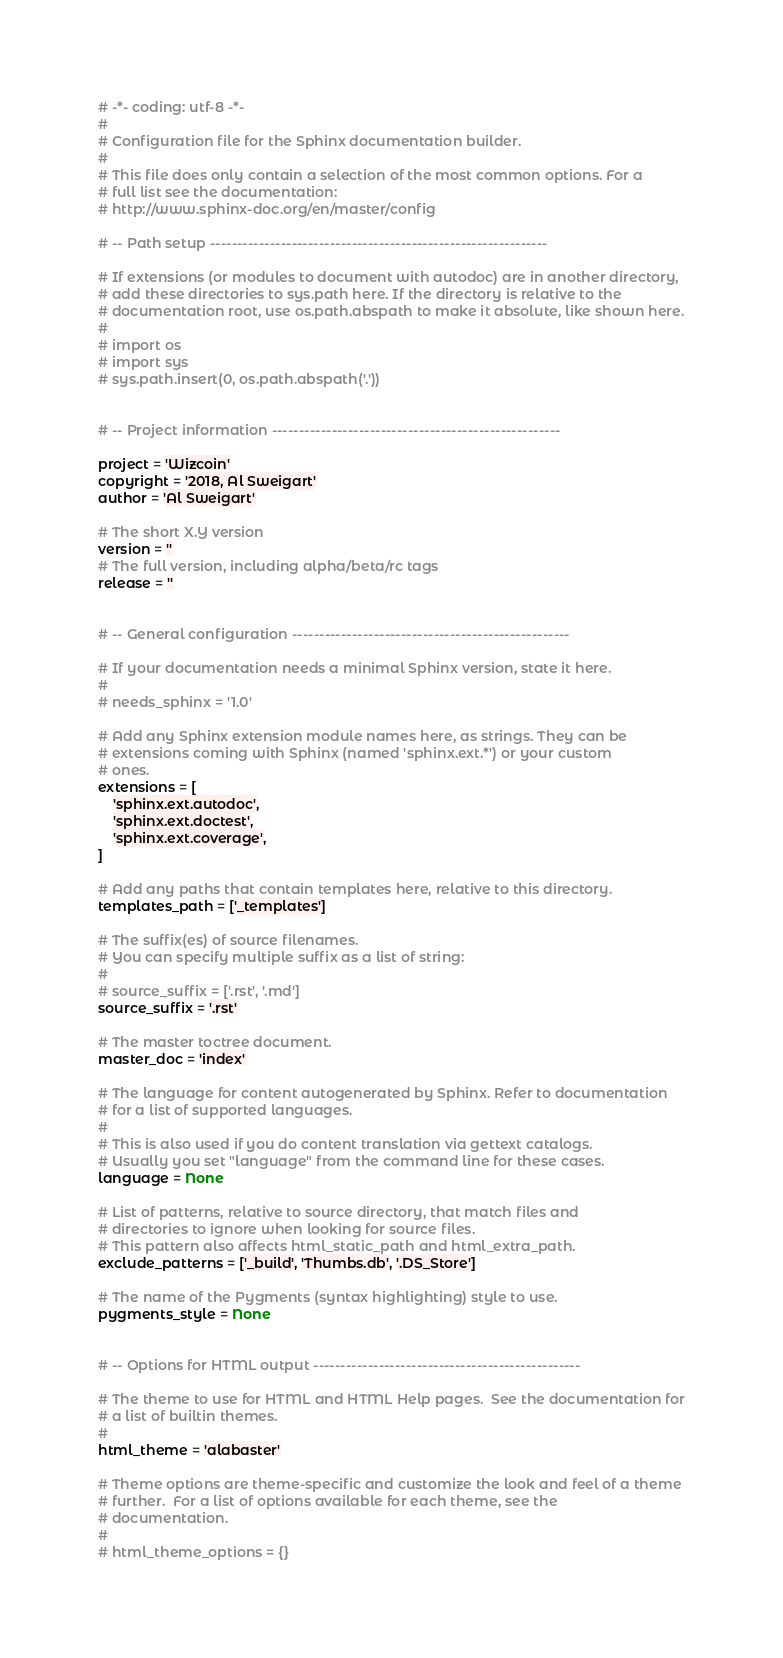Convert code to text. <code><loc_0><loc_0><loc_500><loc_500><_Python_># -*- coding: utf-8 -*-
#
# Configuration file for the Sphinx documentation builder.
#
# This file does only contain a selection of the most common options. For a
# full list see the documentation:
# http://www.sphinx-doc.org/en/master/config

# -- Path setup --------------------------------------------------------------

# If extensions (or modules to document with autodoc) are in another directory,
# add these directories to sys.path here. If the directory is relative to the
# documentation root, use os.path.abspath to make it absolute, like shown here.
#
# import os
# import sys
# sys.path.insert(0, os.path.abspath('.'))


# -- Project information -----------------------------------------------------

project = 'Wizcoin'
copyright = '2018, Al Sweigart'
author = 'Al Sweigart'

# The short X.Y version
version = ''
# The full version, including alpha/beta/rc tags
release = ''


# -- General configuration ---------------------------------------------------

# If your documentation needs a minimal Sphinx version, state it here.
#
# needs_sphinx = '1.0'

# Add any Sphinx extension module names here, as strings. They can be
# extensions coming with Sphinx (named 'sphinx.ext.*') or your custom
# ones.
extensions = [
    'sphinx.ext.autodoc',
    'sphinx.ext.doctest',
    'sphinx.ext.coverage',
]

# Add any paths that contain templates here, relative to this directory.
templates_path = ['_templates']

# The suffix(es) of source filenames.
# You can specify multiple suffix as a list of string:
#
# source_suffix = ['.rst', '.md']
source_suffix = '.rst'

# The master toctree document.
master_doc = 'index'

# The language for content autogenerated by Sphinx. Refer to documentation
# for a list of supported languages.
#
# This is also used if you do content translation via gettext catalogs.
# Usually you set "language" from the command line for these cases.
language = None

# List of patterns, relative to source directory, that match files and
# directories to ignore when looking for source files.
# This pattern also affects html_static_path and html_extra_path.
exclude_patterns = ['_build', 'Thumbs.db', '.DS_Store']

# The name of the Pygments (syntax highlighting) style to use.
pygments_style = None


# -- Options for HTML output -------------------------------------------------

# The theme to use for HTML and HTML Help pages.  See the documentation for
# a list of builtin themes.
#
html_theme = 'alabaster'

# Theme options are theme-specific and customize the look and feel of a theme
# further.  For a list of options available for each theme, see the
# documentation.
#
# html_theme_options = {}
</code> 